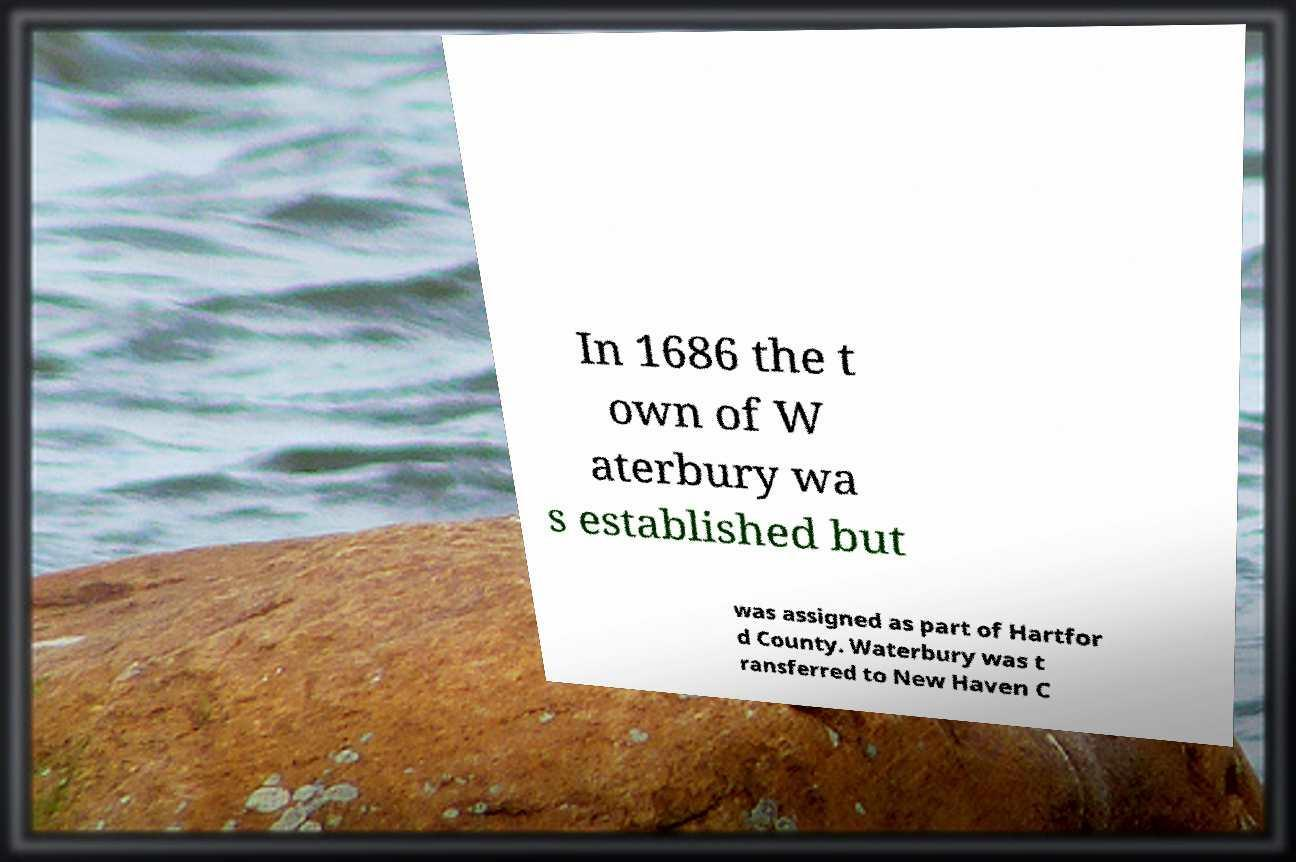Could you extract and type out the text from this image? In 1686 the t own of W aterbury wa s established but was assigned as part of Hartfor d County. Waterbury was t ransferred to New Haven C 